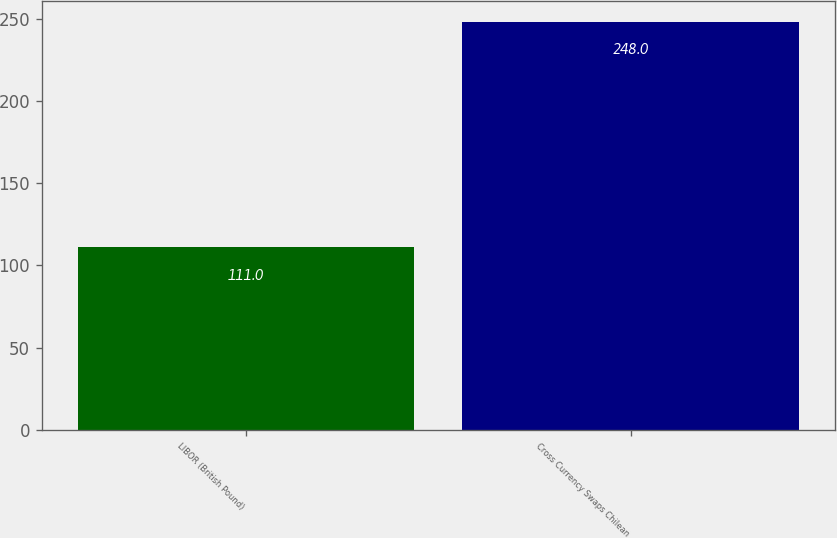<chart> <loc_0><loc_0><loc_500><loc_500><bar_chart><fcel>LIBOR (British Pound)<fcel>Cross Currency Swaps Chilean<nl><fcel>111<fcel>248<nl></chart> 